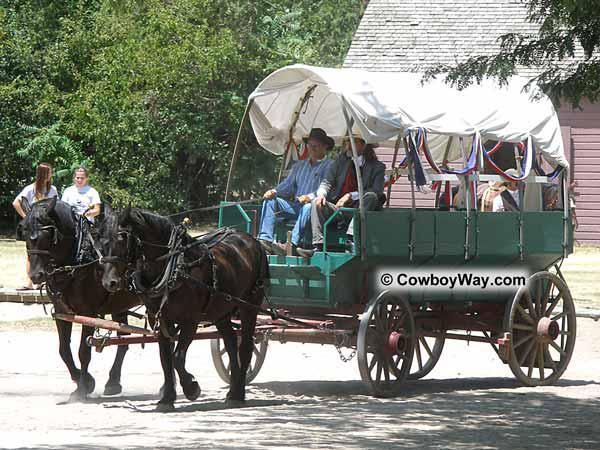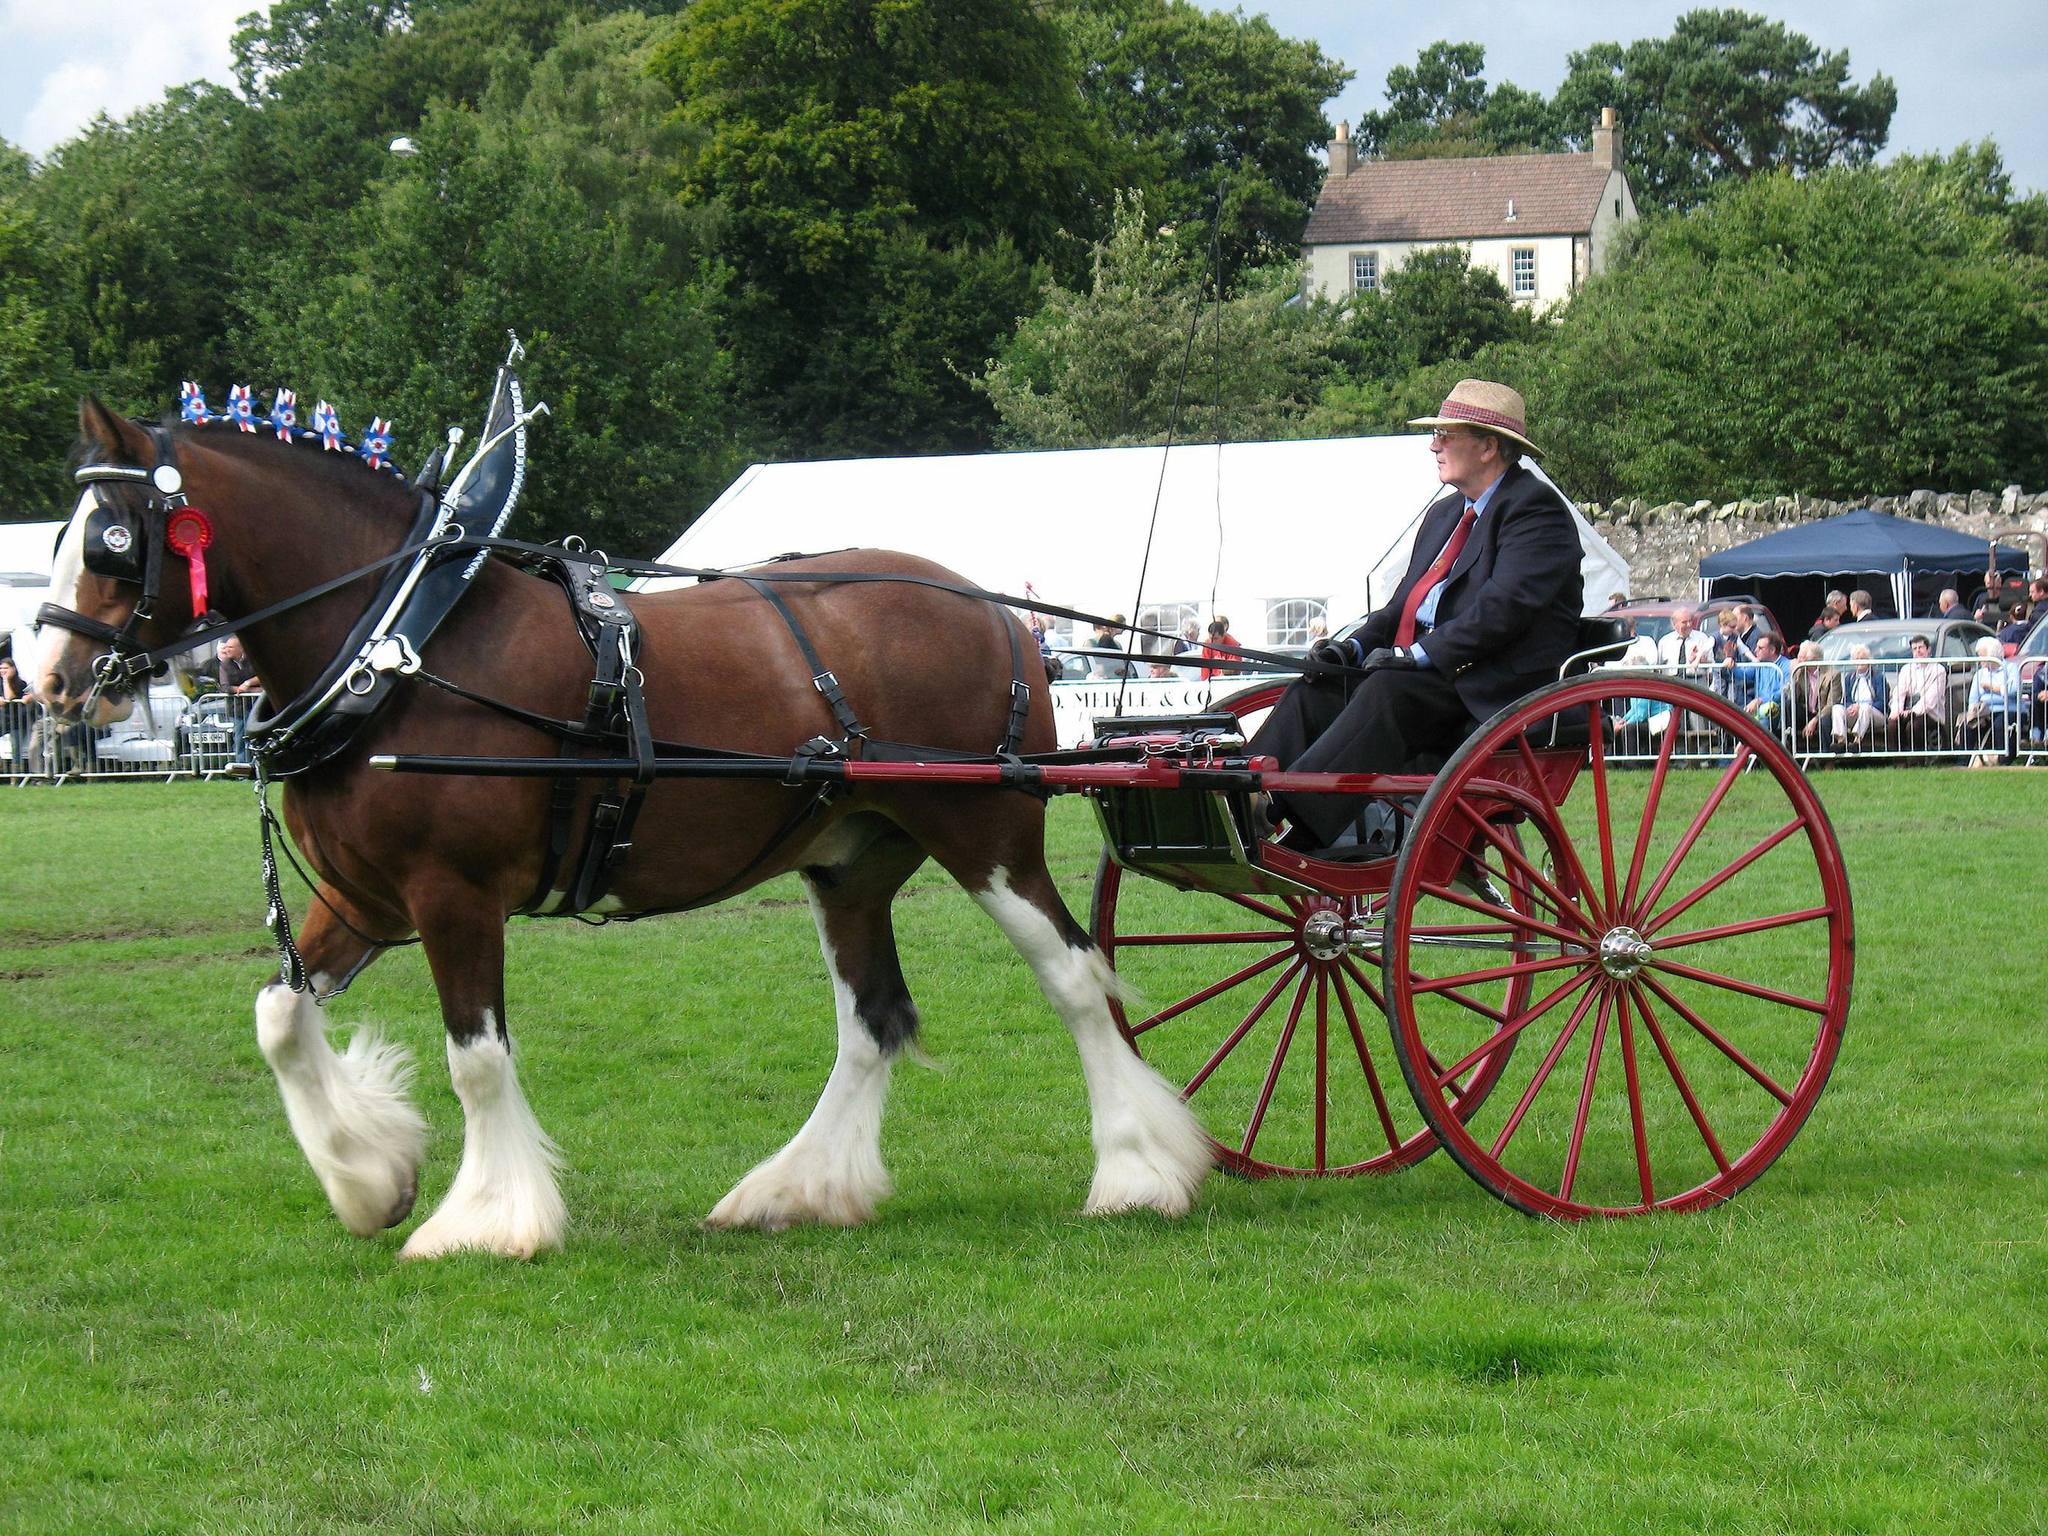The first image is the image on the left, the second image is the image on the right. For the images displayed, is the sentence "At least one horse is black." factually correct? Answer yes or no. Yes. 